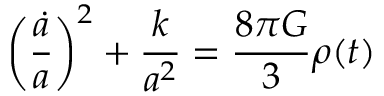<formula> <loc_0><loc_0><loc_500><loc_500>\left ( { \frac { \dot { a } } { a } } \right ) ^ { 2 } + { \frac { k } { a ^ { 2 } } } = { \frac { 8 \pi G } { 3 } } \rho ( t )</formula> 